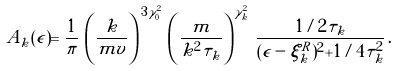<formula> <loc_0><loc_0><loc_500><loc_500>A _ { k } ( \epsilon ) = \frac { 1 } { \pi } \, \left ( \frac { k } { m v } \right ) ^ { \, 3 \gamma _ { 0 } ^ { 2 } } \, \left ( \frac { m } { k ^ { 2 } \tau _ { k } } \right ) ^ { \gamma _ { k } ^ { 2 } } \, \frac { 1 / 2 \tau _ { k } } { ( \epsilon - \xi _ { k } ^ { R } ) ^ { 2 } + 1 / 4 \tau _ { k } ^ { 2 } } \, .</formula> 